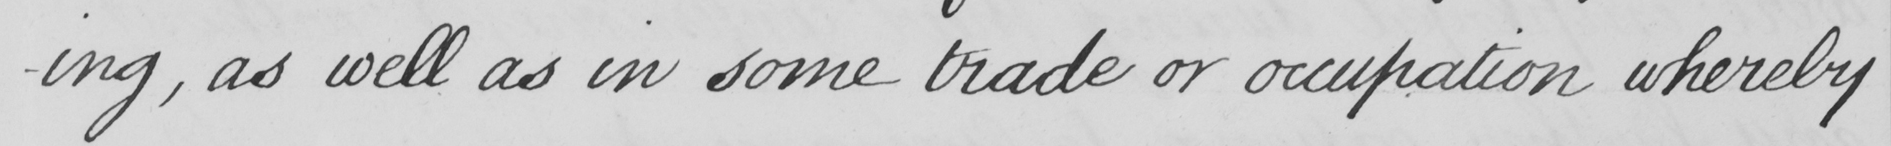What text is written in this handwritten line? -ing , as well as in some trade or occupation whereby 